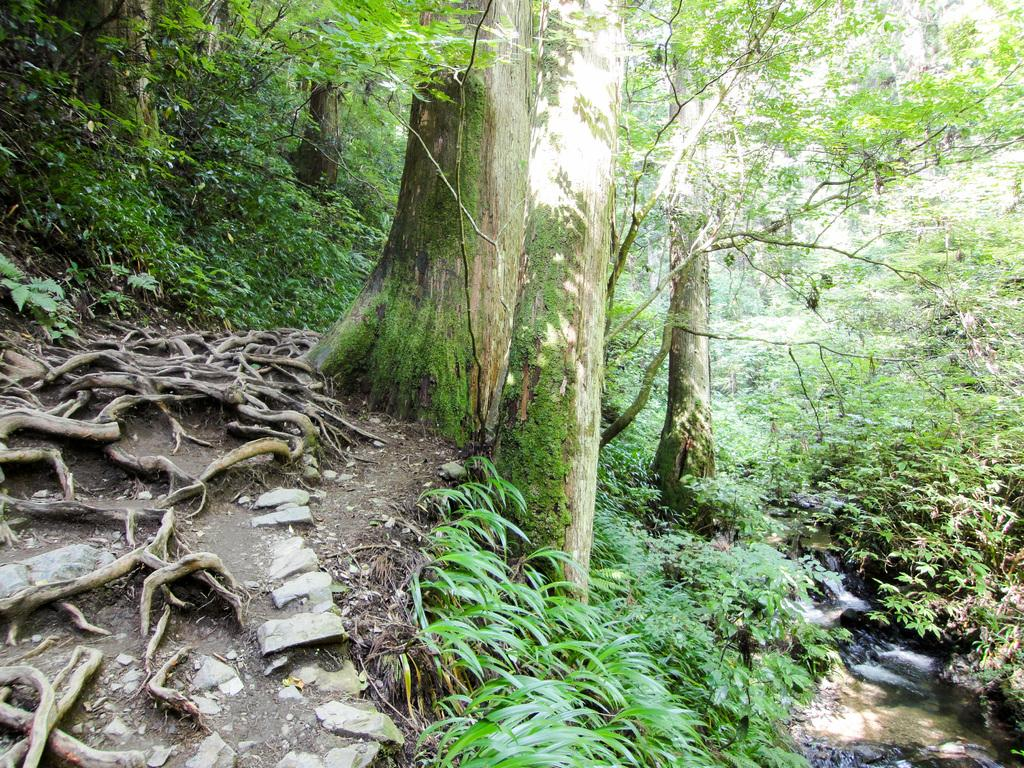What type of vegetation can be seen on the ground in the image? There are trees and plants on the ground in the image. What part of the trees is visible in the image? The roots of the trees are visible in the image. What can be found on the left side of the image? There are stones on the left side of the image. What is happening on the right side of the image? Water is flowing on the ground on the right side of the image. How does the angle of the trees change throughout the image? The angle of the trees does not change throughout the image; they are stationary and upright. 